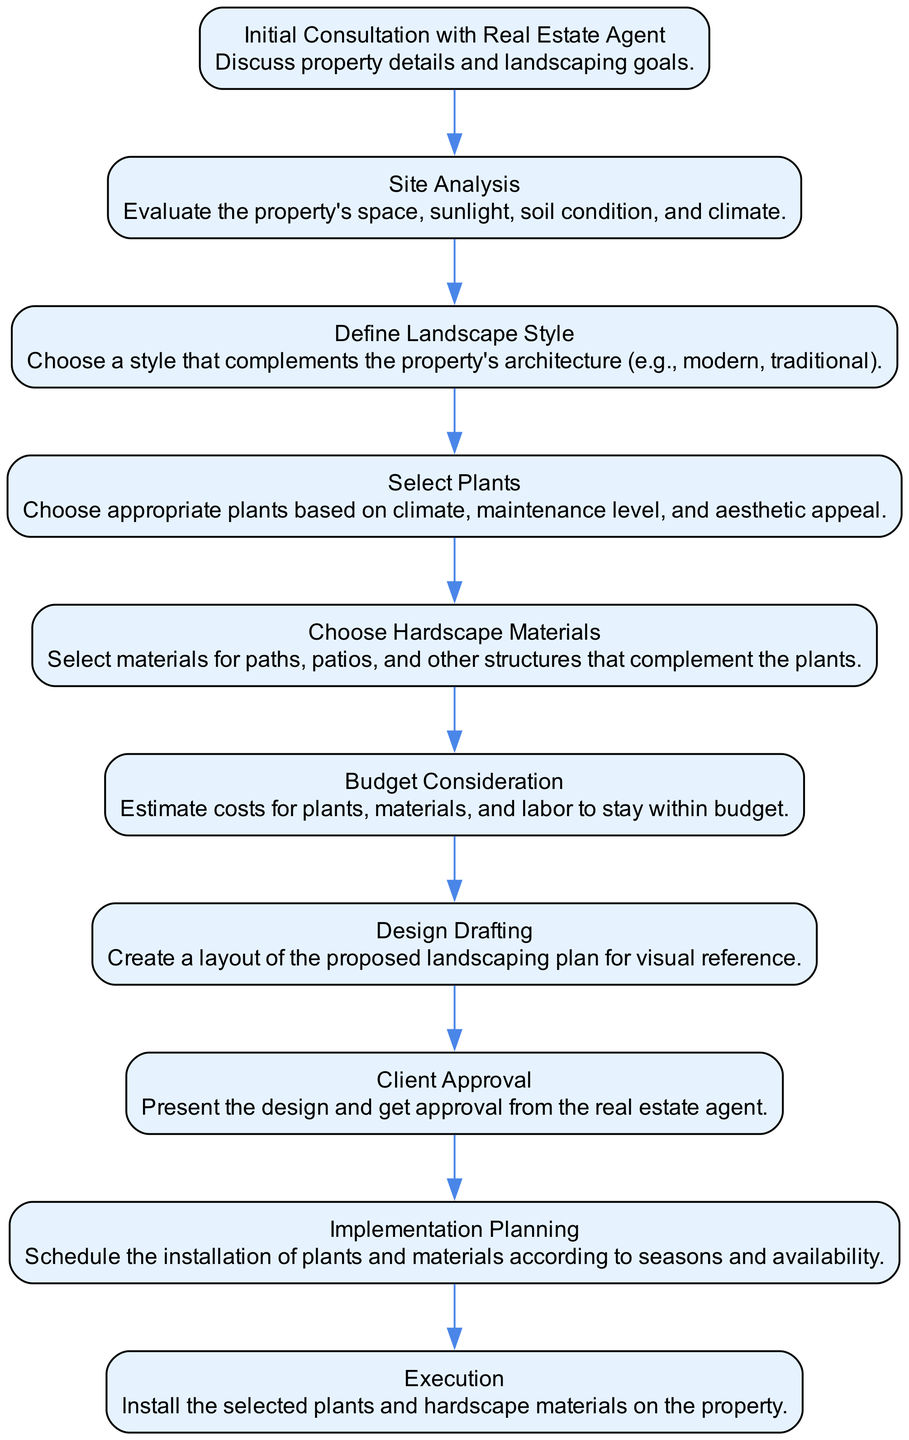What is the first step in the decision-making process? The first step in the process, as illustrated in the diagram, is "Initial Consultation with Real Estate Agent." This step deals with discussing the property details and landscaping goals.
Answer: Initial Consultation with Real Estate Agent How many total steps are there in the process? By counting the nodes in the flow chart, we find there are 10 distinct steps, each representing a key part of the decision-making process.
Answer: 10 What step follows "Define Landscape Style"? The flow chart indicates that the step that follows "Define Landscape Style" is "Select Plants." This flow continues the logical progression of the landscaping process.
Answer: Select Plants Which step involves estimating costs? According to the diagram, the step dedicated to estimating costs is labeled as "Budget Consideration." This step helps ensure the project stays within financial constraints.
Answer: Budget Consideration What is the last step in the decision-making process? The final step in the process is "Execution," where the selected plants and hardscape materials are installed on the property, completing the landscaping plan.
Answer: Execution Explain the relationship between "Client Approval" and "Design Drafting." In the flow chart, "Design Drafting" precedes "Client Approval," indicating that a layout of the proposed landscaping plan must be created and presented for approval before moving on to implementation.
Answer: Design Drafting precedes Client Approval What does the "Site Analysis" step evaluate? The "Site Analysis" step evaluates the property's space, sunlight, soil condition, and climate. This assessment is crucial for making informed decisions about plant selection and design.
Answer: Property's space, sunlight, soil condition, and climate Identify one factor considered in the "Select Plants" step. The "Select Plants" step considers several factors, and one of them is the climate. Choosing plants suited to the climate ensures their survival and enhances the landscape aesthetically.
Answer: Climate Which step involves scheduling the installation of materials? The step focused on scheduling the installation of plants and materials is called "Implementation Planning." This step ensures that the timing aligns with seasonal conditions and plant availability.
Answer: Implementation Planning What is the purpose of "Design Drafting"? "Design Drafting" serves to create a visual layout of the proposed landscaping plan. This step provides a reference for both the landscaper and the client to visualize the plan before implementation begins.
Answer: Create a layout of the proposed landscaping plan 